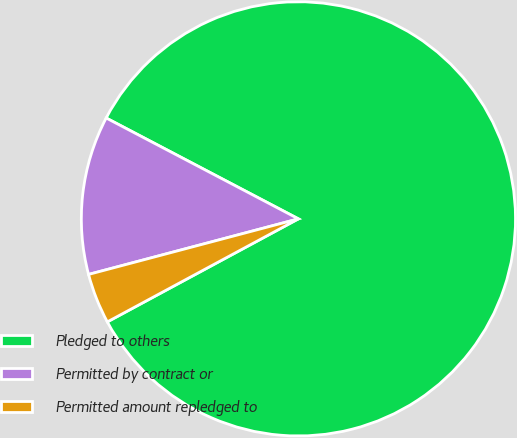<chart> <loc_0><loc_0><loc_500><loc_500><pie_chart><fcel>Pledged to others<fcel>Permitted by contract or<fcel>Permitted amount repledged to<nl><fcel>84.44%<fcel>11.81%<fcel>3.75%<nl></chart> 